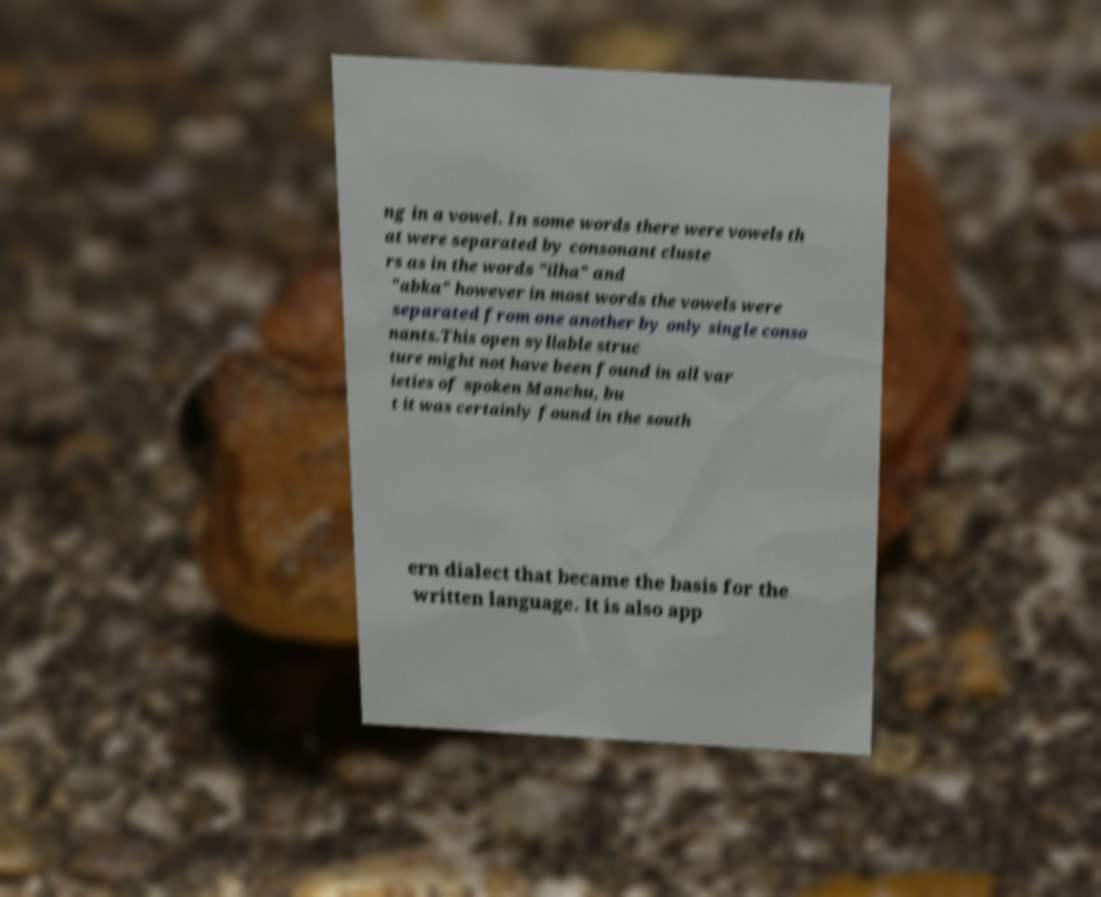For documentation purposes, I need the text within this image transcribed. Could you provide that? ng in a vowel. In some words there were vowels th at were separated by consonant cluste rs as in the words "ilha" and "abka" however in most words the vowels were separated from one another by only single conso nants.This open syllable struc ture might not have been found in all var ieties of spoken Manchu, bu t it was certainly found in the south ern dialect that became the basis for the written language. It is also app 